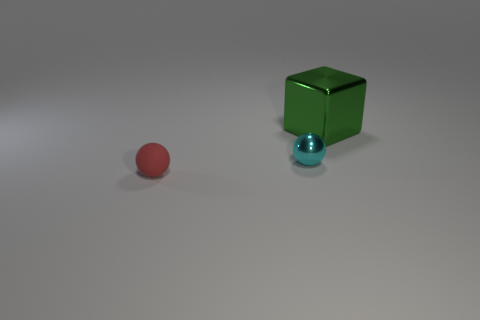Add 3 metallic cubes. How many objects exist? 6 Subtract 1 cubes. How many cubes are left? 0 Subtract all cyan spheres. How many spheres are left? 1 Subtract all spheres. How many objects are left? 1 Subtract all green cylinders. How many cyan spheres are left? 1 Add 3 small things. How many small things are left? 5 Add 2 large green metal objects. How many large green metal objects exist? 3 Subtract 0 brown cylinders. How many objects are left? 3 Subtract all green spheres. Subtract all brown cylinders. How many spheres are left? 2 Subtract all green blocks. Subtract all large cyan shiny balls. How many objects are left? 2 